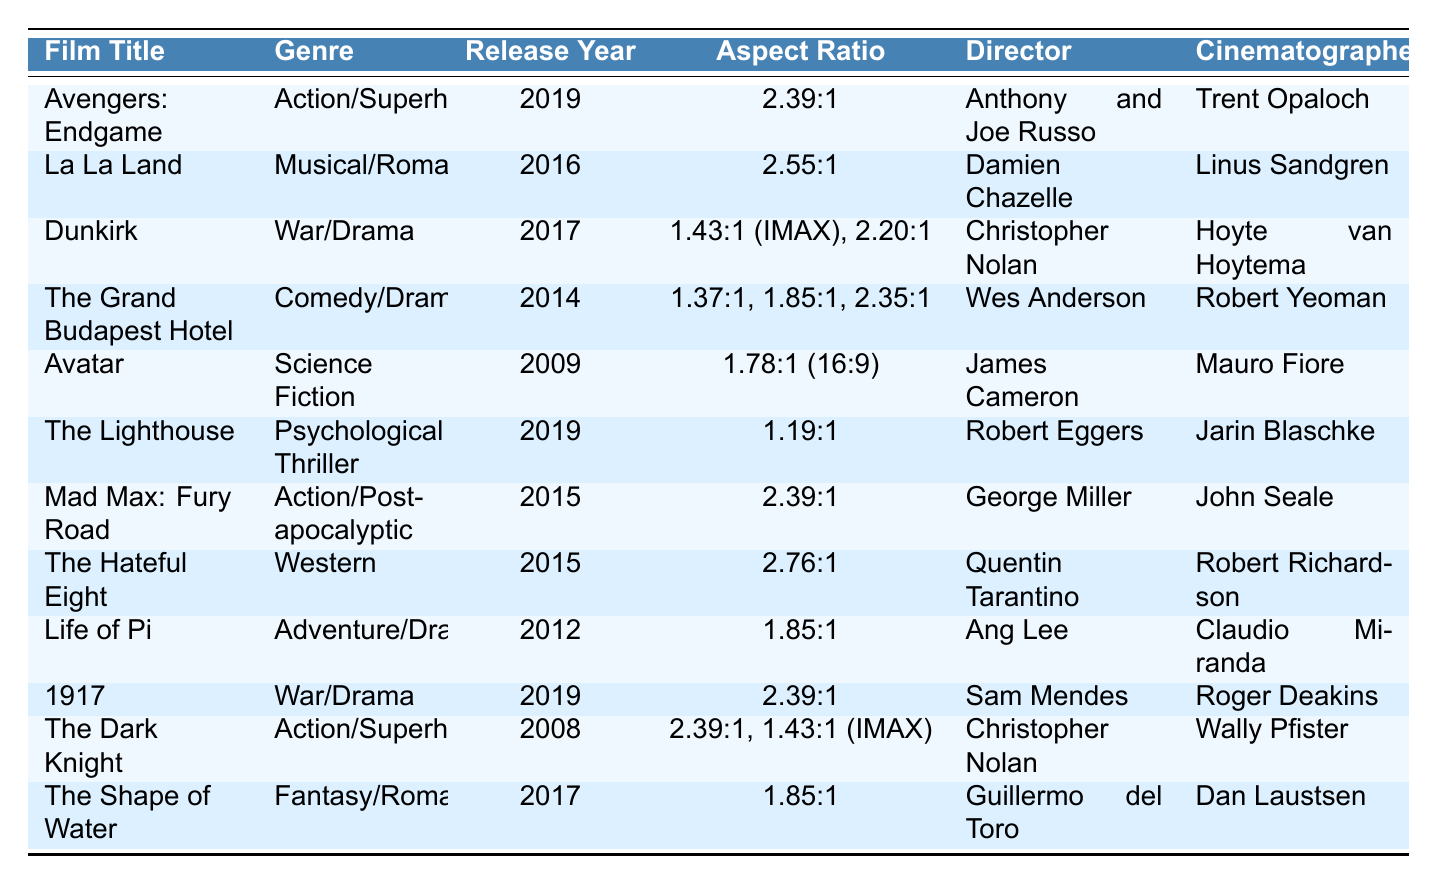What is the aspect ratio of "Avatar"? The table lists the aspect ratio of "Avatar" under the Aspect Ratio column, which is 1.78:1 (16:9).
Answer: 1.78:1 (16:9) Which film has the widest aspect ratio? By comparing the aspect ratios in the table, "The Hateful Eight" has the widest aspect ratio of 2.76:1.
Answer: 2.76:1 How many films listed have an aspect ratio of 2.39:1? Counting the entries in the Aspect Ratio column for 2.39:1, we find that there are four films: "Avengers: Endgame," "Mad Max: Fury Road," "1917," and "The Dark Knight."
Answer: 4 Is "Dunkirk" directed by Christopher Nolan? The table indicates that "Dunkirk" is indeed directed by Christopher Nolan.
Answer: Yes Which genres are represented by films with an aspect ratio of 1.85:1? Looking through the table, "Life of Pi" and "The Shape of Water" are both in genres (Adventure/Drama and Fantasy/Romance, respectively) with an aspect ratio of 1.85:1.
Answer: Adventure/Drama, Fantasy/Romance What is the release year range for films that use the aspect ratio of 2.39:1? The films with an aspect ratio of 2.39:1 include "Avengers: Endgame" (2019), "Mad Max: Fury Road" (2015), "1917" (2019), and "The Dark Knight" (2008). The release year range is 2008 to 2019.
Answer: 2008 to 2019 How many different aspect ratios are used in "The Grand Budapest Hotel"? The table shows that "The Grand Budapest Hotel" uses three different aspect ratios: 1.37:1, 1.85:1, and 2.35:1.
Answer: 3 Which director has the highest number of films listed in the table? The table shows that Christopher Nolan directed two films ("Dunkirk" and "The Dark Knight"), which is the highest number among the listed films.
Answer: Christopher Nolan What is the average aspect ratio of the films in the "Action/Superhero" genre? The films in this genre listed are "Avengers: Endgame" (2.39:1) and "The Dark Knight" (which has multiple ratios: 2.39:1 and 1.43:1). To find the average, convert these ratios to decimal (2.39 and 1.43) and average them. (2.39 + 2.39 + 1.43)/3 = 2.07 (approx).
Answer: 2.07 What percentage of the films listed are categorized as "War/Drama"? There are two films in the "War/Drama" category: "Dunkirk" and "1917". To find the percentage: (2/12) * 100 = 16.67%.
Answer: 16.67% Is there a film with an aspect ratio under 1.5:1? "The Lighthouse" has an aspect ratio of 1.19:1, which is under 1.5:1.
Answer: Yes 